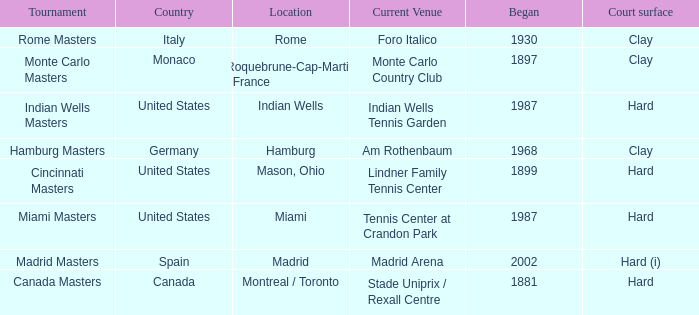Which tournaments current venue is the Madrid Arena? Madrid Masters. 